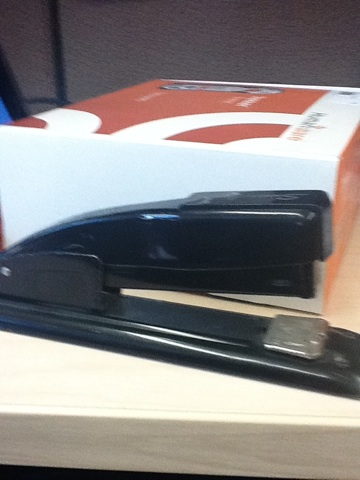I guess I'm getting onto Wi-Fi, and then I record a question, like what is this black thing? The black object in the image is a stapler, a common office tool used for binding sheets of paper together by driving a metal staple through the sheets and folding the ends. 